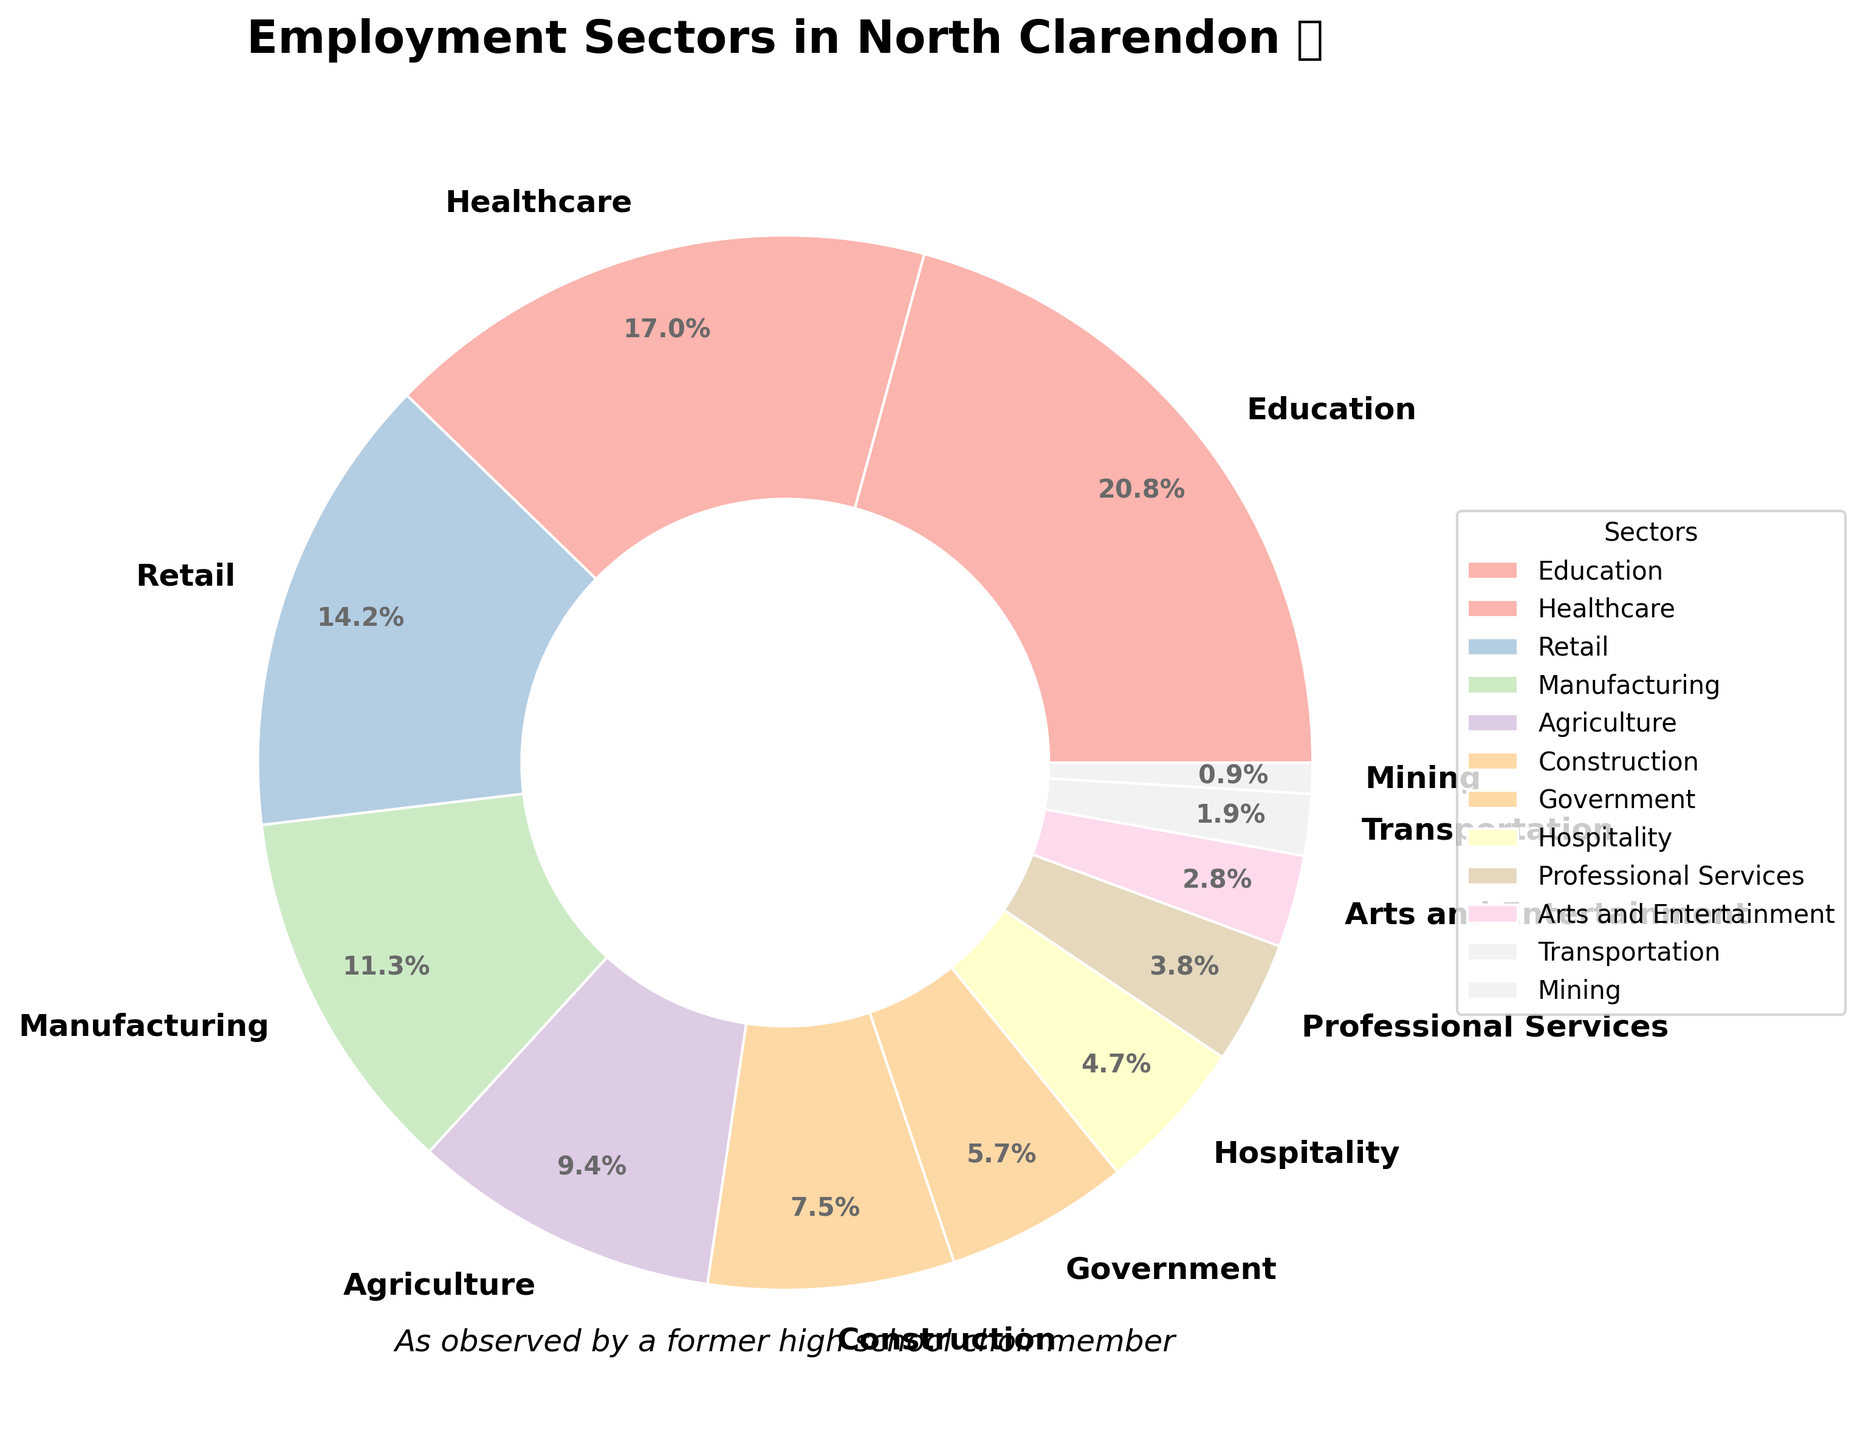what sector constitutes the largest percentage of employment in North Clarendon? To identify the largest sector, observe the sector that occupies the largest area in the pie chart. The sector labeled "Education" has the largest area.
Answer: Education How much larger is the employment percentage in Healthcare compared to Retail? Check the percentages for Healthcare (18%) and Retail (15%) and find the difference: 18% - 15% = 3%.
Answer: 3% Which two sectors combined make up more than 30% of the employment? Look for sectors whose combined percentages exceed 30%. Education (22%) and Healthcare (18%) combined make up 40%, which is more than 30%.
Answer: Education and Healthcare What is the percentage difference between Agriculture and Manufacturing sectors? Compare the percentages for Agriculture (10%) and Manufacturing (12%) and calculate the difference: 12% - 10% = 2%.
Answer: 2% Which sector has a smaller employment percentage: Hospitality or Arts and Entertainment? Compare the percentages directly from the pie chart. Hospitality has 5% and Arts and Entertainment has 3%, so Arts and Entertainment is smaller.
Answer: Arts and Entertainment If the employment from Government and Professional Services sectors are combined, what percentage does it form? Add the percentages for Government (6%) and Professional Services (4%): 6% + 4% = 10%.
Answer: 10% What is the combined employment percentage for sectors with 5% or less? Sum the percentages for sectors with 5% or less: Hospitality (5%), Professional Services (4%), Arts and Entertainment (3%), Transportation (2%), and Mining (1%): 5% + 4% + 3% + 2% + 1% = 15%.
Answer: 15% Which sector has the least representation in the employment breakdown? Identify the sector with the smallest segment in the pie chart. Mining has the smallest segment at 1%.
Answer: Mining 